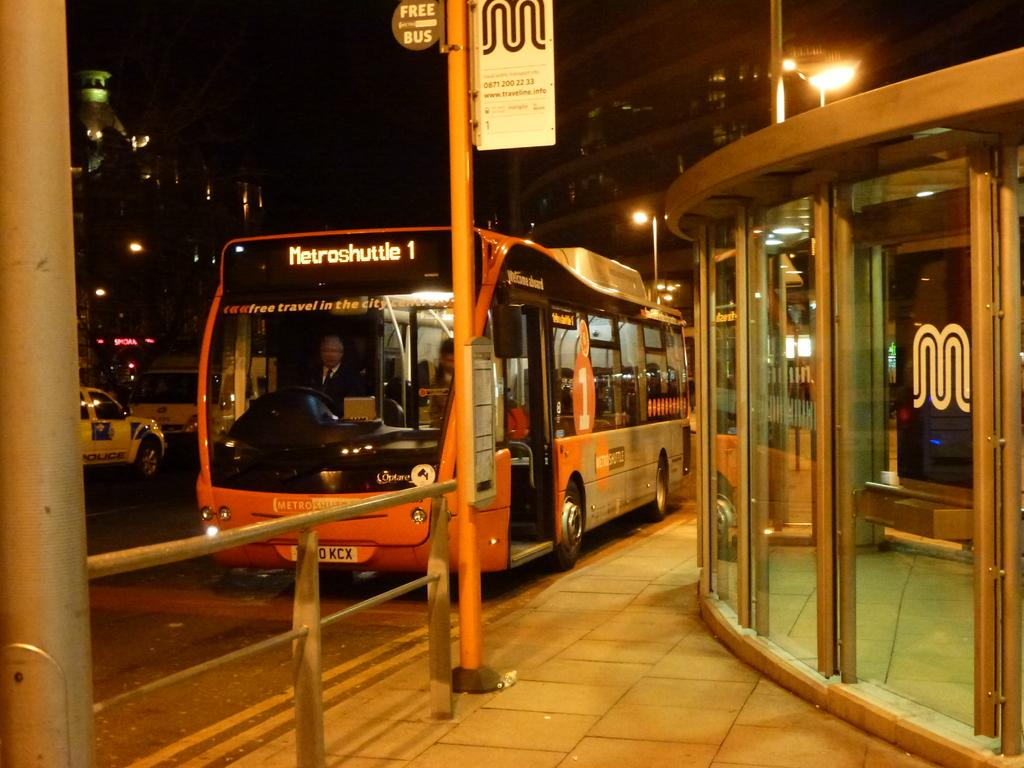What type of path can be seen in the image? There is a footpath in the image. What structures are present along the footpath? There are poles and name boards visible in the image. What mode of transportation can be seen on the road in the image? Vehicles are visible on the road in the image. What type of structures are visible in the background? There are buildings in the image. What type of illumination is present in the image? Lights are present in the image. What else can be seen in the image? There are some objects in the image. Can you describe the people in the image? Two people are inside a bus in the image. How would you describe the overall appearance of the image? The background of the image is dark. Where is the shop selling cherries in the image? There is no shop selling cherries present in the image. What type of mailbox can be seen near the bus stop in the image? There is no mailbox present in the image. 